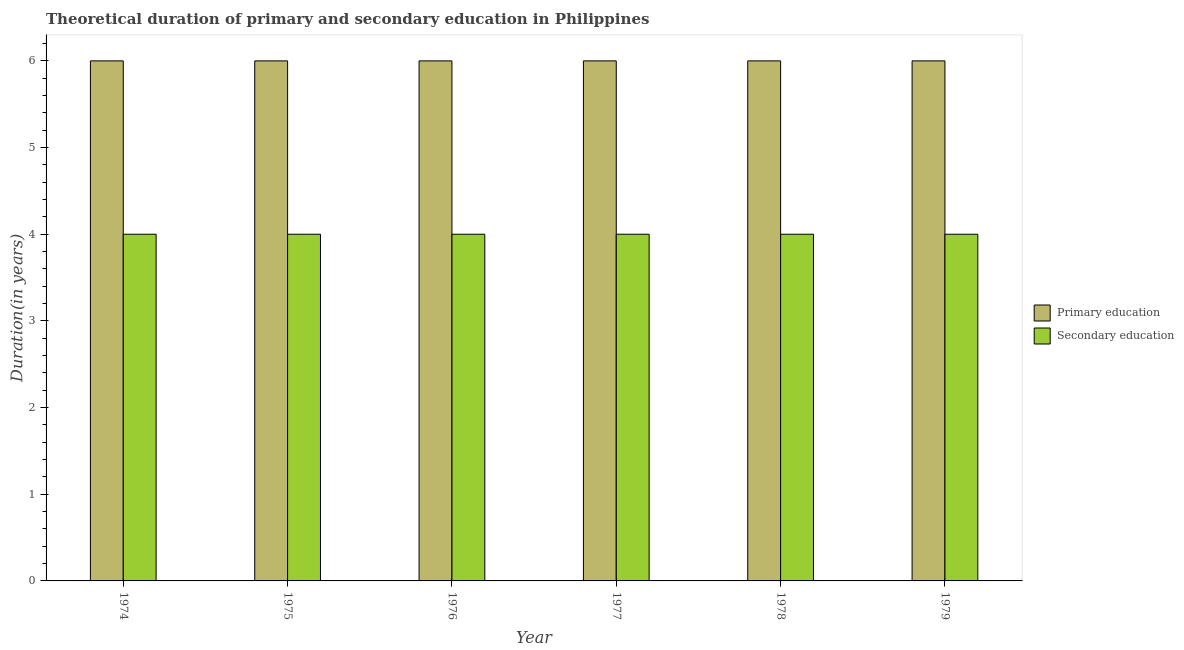How many bars are there on the 1st tick from the left?
Keep it short and to the point. 2. How many bars are there on the 3rd tick from the right?
Provide a short and direct response. 2. What is the label of the 2nd group of bars from the left?
Your answer should be compact. 1975. What is the duration of primary education in 1978?
Your answer should be compact. 6. Across all years, what is the maximum duration of secondary education?
Give a very brief answer. 4. Across all years, what is the minimum duration of primary education?
Your response must be concise. 6. In which year was the duration of primary education maximum?
Give a very brief answer. 1974. In which year was the duration of secondary education minimum?
Offer a terse response. 1974. What is the total duration of secondary education in the graph?
Keep it short and to the point. 24. What is the difference between the duration of secondary education in 1976 and the duration of primary education in 1979?
Provide a succinct answer. 0. What is the average duration of secondary education per year?
Keep it short and to the point. 4. In how many years, is the duration of secondary education greater than 3 years?
Your answer should be very brief. 6. Is the duration of secondary education in 1974 less than that in 1978?
Provide a short and direct response. No. Is the difference between the duration of primary education in 1975 and 1976 greater than the difference between the duration of secondary education in 1975 and 1976?
Make the answer very short. No. What is the difference between the highest and the second highest duration of secondary education?
Make the answer very short. 0. What is the difference between the highest and the lowest duration of secondary education?
Offer a very short reply. 0. What does the 1st bar from the left in 1979 represents?
Give a very brief answer. Primary education. What does the 2nd bar from the right in 1978 represents?
Make the answer very short. Primary education. Are the values on the major ticks of Y-axis written in scientific E-notation?
Keep it short and to the point. No. Does the graph contain grids?
Give a very brief answer. No. How many legend labels are there?
Ensure brevity in your answer.  2. What is the title of the graph?
Ensure brevity in your answer.  Theoretical duration of primary and secondary education in Philippines. Does "Adolescent fertility rate" appear as one of the legend labels in the graph?
Your response must be concise. No. What is the label or title of the Y-axis?
Keep it short and to the point. Duration(in years). What is the Duration(in years) in Primary education in 1974?
Offer a terse response. 6. What is the Duration(in years) of Secondary education in 1974?
Keep it short and to the point. 4. What is the Duration(in years) of Secondary education in 1975?
Ensure brevity in your answer.  4. What is the Duration(in years) in Secondary education in 1976?
Offer a very short reply. 4. What is the Duration(in years) of Primary education in 1977?
Give a very brief answer. 6. What is the Duration(in years) in Primary education in 1978?
Your answer should be very brief. 6. What is the Duration(in years) in Primary education in 1979?
Provide a succinct answer. 6. Across all years, what is the maximum Duration(in years) in Secondary education?
Your response must be concise. 4. Across all years, what is the minimum Duration(in years) of Primary education?
Keep it short and to the point. 6. Across all years, what is the minimum Duration(in years) in Secondary education?
Offer a terse response. 4. What is the difference between the Duration(in years) in Primary education in 1974 and that in 1975?
Offer a terse response. 0. What is the difference between the Duration(in years) of Secondary education in 1974 and that in 1975?
Keep it short and to the point. 0. What is the difference between the Duration(in years) in Primary education in 1974 and that in 1976?
Provide a succinct answer. 0. What is the difference between the Duration(in years) of Primary education in 1974 and that in 1977?
Provide a succinct answer. 0. What is the difference between the Duration(in years) of Secondary education in 1974 and that in 1977?
Offer a very short reply. 0. What is the difference between the Duration(in years) in Secondary education in 1974 and that in 1978?
Your answer should be compact. 0. What is the difference between the Duration(in years) in Primary education in 1975 and that in 1976?
Provide a succinct answer. 0. What is the difference between the Duration(in years) in Secondary education in 1975 and that in 1976?
Keep it short and to the point. 0. What is the difference between the Duration(in years) of Secondary education in 1975 and that in 1977?
Provide a succinct answer. 0. What is the difference between the Duration(in years) in Secondary education in 1975 and that in 1978?
Offer a very short reply. 0. What is the difference between the Duration(in years) in Primary education in 1975 and that in 1979?
Keep it short and to the point. 0. What is the difference between the Duration(in years) of Secondary education in 1976 and that in 1977?
Provide a short and direct response. 0. What is the difference between the Duration(in years) in Primary education in 1976 and that in 1979?
Provide a succinct answer. 0. What is the difference between the Duration(in years) in Secondary education in 1977 and that in 1978?
Ensure brevity in your answer.  0. What is the difference between the Duration(in years) of Primary education in 1977 and that in 1979?
Keep it short and to the point. 0. What is the difference between the Duration(in years) of Secondary education in 1978 and that in 1979?
Keep it short and to the point. 0. What is the difference between the Duration(in years) in Primary education in 1974 and the Duration(in years) in Secondary education in 1975?
Your answer should be very brief. 2. What is the difference between the Duration(in years) in Primary education in 1974 and the Duration(in years) in Secondary education in 1976?
Keep it short and to the point. 2. What is the difference between the Duration(in years) of Primary education in 1974 and the Duration(in years) of Secondary education in 1979?
Offer a very short reply. 2. What is the difference between the Duration(in years) of Primary education in 1975 and the Duration(in years) of Secondary education in 1976?
Your answer should be very brief. 2. What is the difference between the Duration(in years) in Primary education in 1975 and the Duration(in years) in Secondary education in 1978?
Your answer should be very brief. 2. What is the difference between the Duration(in years) in Primary education in 1977 and the Duration(in years) in Secondary education in 1978?
Your response must be concise. 2. What is the difference between the Duration(in years) in Primary education in 1977 and the Duration(in years) in Secondary education in 1979?
Keep it short and to the point. 2. What is the difference between the Duration(in years) of Primary education in 1978 and the Duration(in years) of Secondary education in 1979?
Ensure brevity in your answer.  2. In the year 1974, what is the difference between the Duration(in years) in Primary education and Duration(in years) in Secondary education?
Offer a terse response. 2. In the year 1975, what is the difference between the Duration(in years) in Primary education and Duration(in years) in Secondary education?
Your answer should be compact. 2. In the year 1979, what is the difference between the Duration(in years) in Primary education and Duration(in years) in Secondary education?
Your answer should be compact. 2. What is the ratio of the Duration(in years) in Primary education in 1974 to that in 1976?
Your answer should be very brief. 1. What is the ratio of the Duration(in years) in Primary education in 1974 to that in 1977?
Provide a short and direct response. 1. What is the ratio of the Duration(in years) of Secondary education in 1974 to that in 1977?
Offer a very short reply. 1. What is the ratio of the Duration(in years) of Primary education in 1974 to that in 1979?
Keep it short and to the point. 1. What is the ratio of the Duration(in years) in Secondary education in 1974 to that in 1979?
Your answer should be very brief. 1. What is the ratio of the Duration(in years) in Secondary education in 1975 to that in 1976?
Offer a very short reply. 1. What is the ratio of the Duration(in years) in Primary education in 1975 to that in 1977?
Give a very brief answer. 1. What is the ratio of the Duration(in years) of Secondary education in 1975 to that in 1978?
Your answer should be compact. 1. What is the ratio of the Duration(in years) of Primary education in 1975 to that in 1979?
Your answer should be very brief. 1. What is the ratio of the Duration(in years) of Secondary education in 1975 to that in 1979?
Your answer should be very brief. 1. What is the ratio of the Duration(in years) of Secondary education in 1976 to that in 1977?
Your response must be concise. 1. What is the ratio of the Duration(in years) of Primary education in 1976 to that in 1978?
Offer a very short reply. 1. What is the ratio of the Duration(in years) of Secondary education in 1976 to that in 1979?
Your response must be concise. 1. What is the ratio of the Duration(in years) in Secondary education in 1977 to that in 1978?
Provide a succinct answer. 1. What is the ratio of the Duration(in years) of Secondary education in 1978 to that in 1979?
Offer a very short reply. 1. What is the difference between the highest and the second highest Duration(in years) of Secondary education?
Your answer should be very brief. 0. What is the difference between the highest and the lowest Duration(in years) in Primary education?
Keep it short and to the point. 0. What is the difference between the highest and the lowest Duration(in years) of Secondary education?
Keep it short and to the point. 0. 